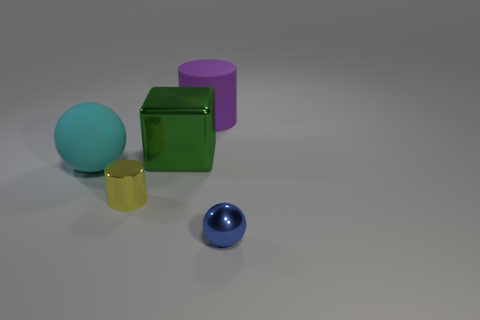Add 2 blue shiny things. How many objects exist? 7 Subtract all spheres. How many objects are left? 3 Subtract 0 cyan blocks. How many objects are left? 5 Subtract all purple things. Subtract all gray shiny balls. How many objects are left? 4 Add 5 tiny metal cylinders. How many tiny metal cylinders are left? 6 Add 4 big cyan shiny cylinders. How many big cyan shiny cylinders exist? 4 